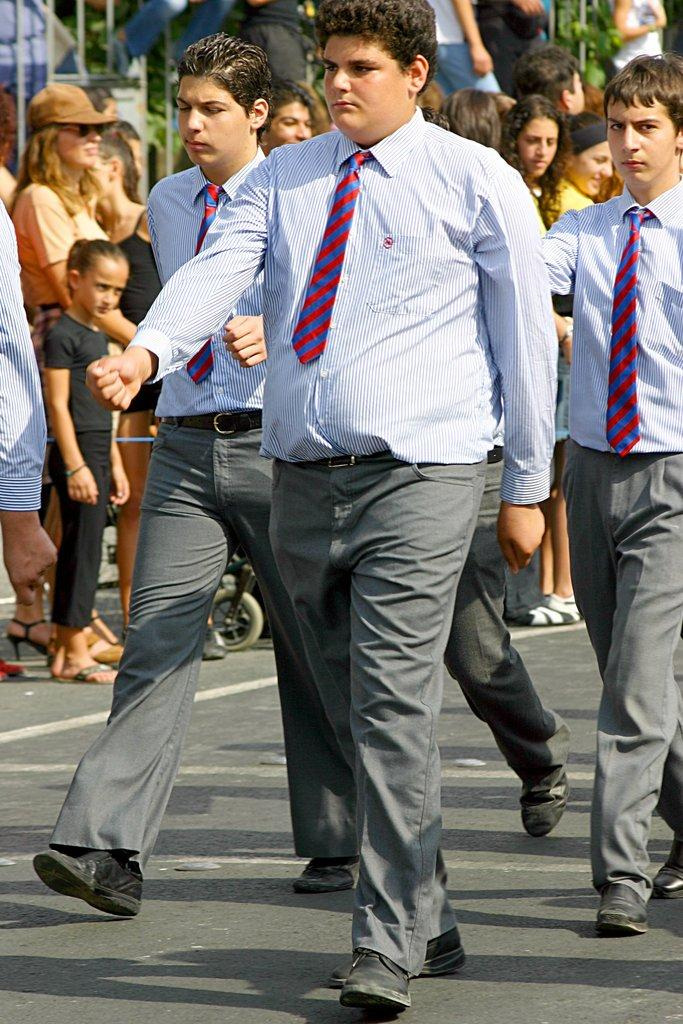What are the people in the image doing? There are people standing and walking in the image. What can be seen in the background of the image? There is a fence and trees in the background of the image. What type of brush is being used by the person in the image? There is no brush present in the image. Who is the partner of the person walking in the image? There is no indication of a partner or any interaction between people in the image. 